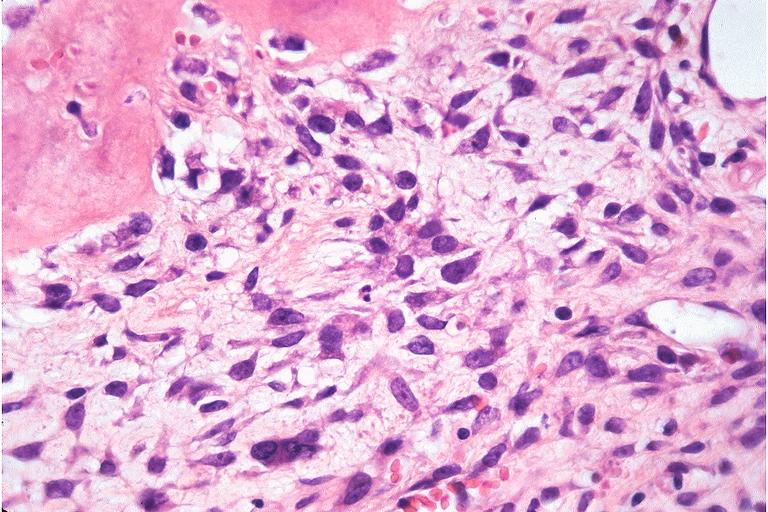what is present?
Answer the question using a single word or phrase. Oral 